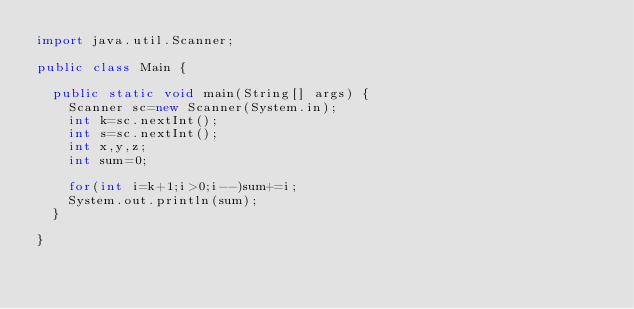<code> <loc_0><loc_0><loc_500><loc_500><_Java_>import java.util.Scanner;

public class Main {

	public static void main(String[] args) {
		Scanner sc=new Scanner(System.in);
		int k=sc.nextInt();
		int s=sc.nextInt();
		int x,y,z;
		int sum=0;
		
		for(int i=k+1;i>0;i--)sum+=i;
		System.out.println(sum);
	}

}
</code> 